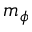<formula> <loc_0><loc_0><loc_500><loc_500>m _ { \phi }</formula> 